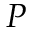<formula> <loc_0><loc_0><loc_500><loc_500>P</formula> 